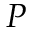<formula> <loc_0><loc_0><loc_500><loc_500>P</formula> 